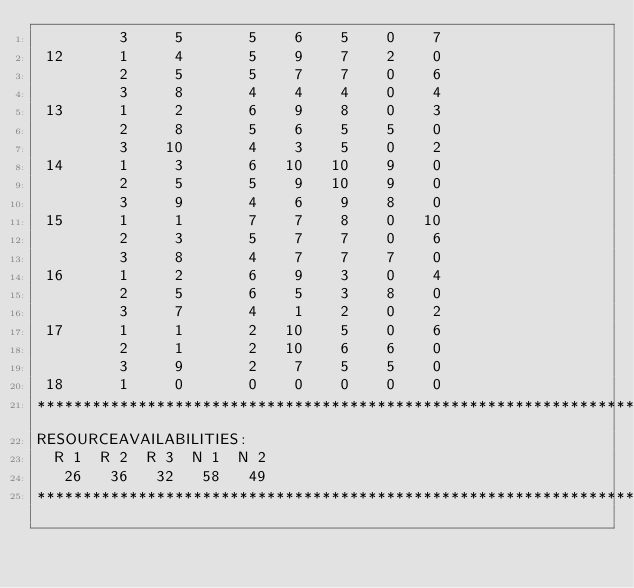<code> <loc_0><loc_0><loc_500><loc_500><_ObjectiveC_>         3     5       5    6    5    0    7
 12      1     4       5    9    7    2    0
         2     5       5    7    7    0    6
         3     8       4    4    4    0    4
 13      1     2       6    9    8    0    3
         2     8       5    6    5    5    0
         3    10       4    3    5    0    2
 14      1     3       6   10   10    9    0
         2     5       5    9   10    9    0
         3     9       4    6    9    8    0
 15      1     1       7    7    8    0   10
         2     3       5    7    7    0    6
         3     8       4    7    7    7    0
 16      1     2       6    9    3    0    4
         2     5       6    5    3    8    0
         3     7       4    1    2    0    2
 17      1     1       2   10    5    0    6
         2     1       2   10    6    6    0
         3     9       2    7    5    5    0
 18      1     0       0    0    0    0    0
************************************************************************
RESOURCEAVAILABILITIES:
  R 1  R 2  R 3  N 1  N 2
   26   36   32   58   49
************************************************************************
</code> 